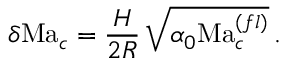<formula> <loc_0><loc_0><loc_500><loc_500>\delta M a _ { c } = \frac { H } { 2 R } \, \sqrt { \alpha _ { 0 } M a _ { c } ^ { ( f l ) } } \, . \</formula> 